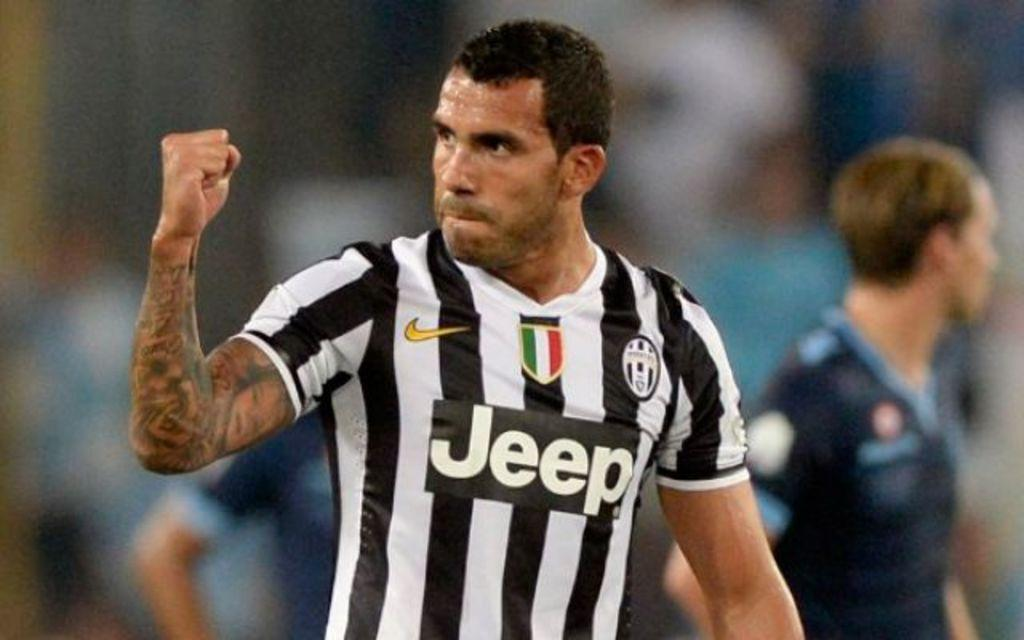<image>
Describe the image concisely. A soccer referee wearing a Jeep branded shirt, and signaling with his arm. 